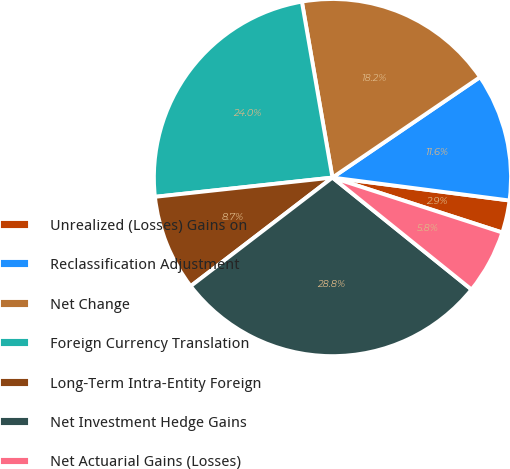<chart> <loc_0><loc_0><loc_500><loc_500><pie_chart><fcel>Unrealized (Losses) Gains on<fcel>Reclassification Adjustment<fcel>Net Change<fcel>Foreign Currency Translation<fcel>Long-Term Intra-Entity Foreign<fcel>Net Investment Hedge Gains<fcel>Net Actuarial Gains (Losses)<nl><fcel>2.93%<fcel>11.56%<fcel>18.23%<fcel>23.98%<fcel>8.68%<fcel>28.81%<fcel>5.81%<nl></chart> 